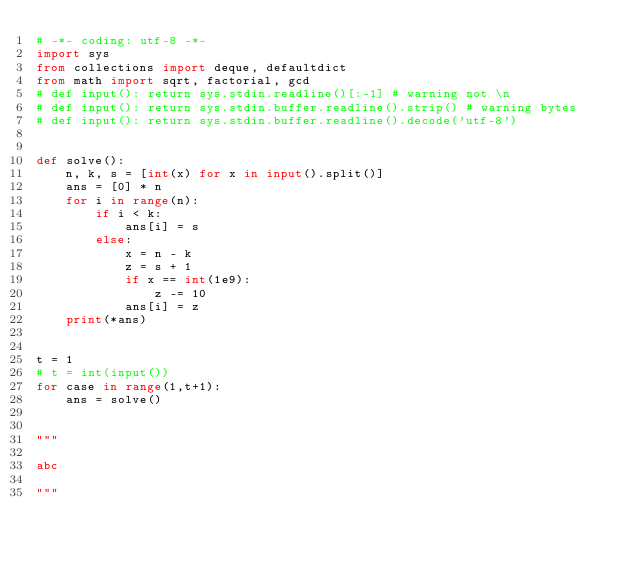Convert code to text. <code><loc_0><loc_0><loc_500><loc_500><_Python_># -*- coding: utf-8 -*-
import sys
from collections import deque, defaultdict
from math import sqrt, factorial, gcd
# def input(): return sys.stdin.readline()[:-1] # warning not \n
# def input(): return sys.stdin.buffer.readline().strip() # warning bytes
# def input(): return sys.stdin.buffer.readline().decode('utf-8')


def solve():
    n, k, s = [int(x) for x in input().split()]
    ans = [0] * n
    for i in range(n):
        if i < k:
            ans[i] = s
        else:
            x = n - k
            z = s + 1
            if x == int(1e9):
                z -= 10
            ans[i] = z
    print(*ans)


t = 1
# t = int(input())
for case in range(1,t+1):
    ans = solve()


"""

abc

"""
</code> 